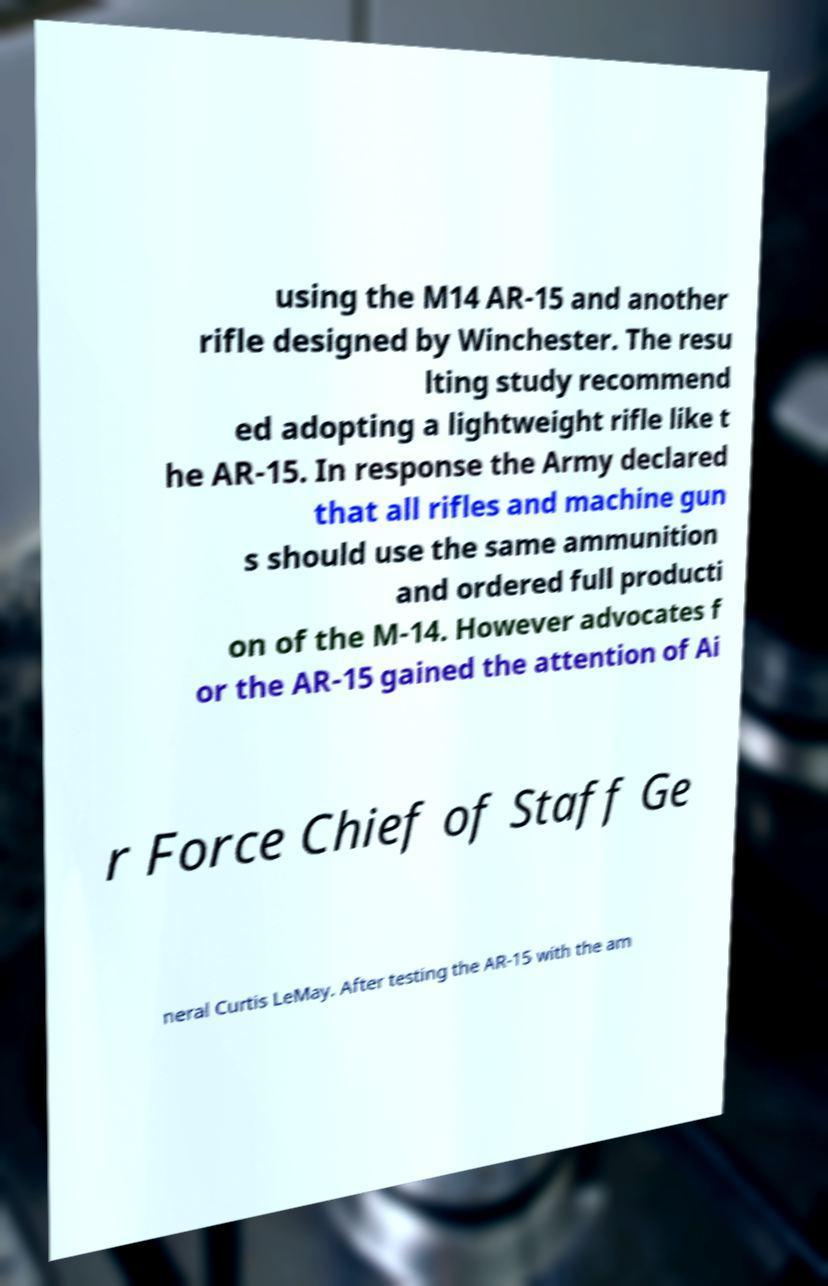Please read and relay the text visible in this image. What does it say? using the M14 AR-15 and another rifle designed by Winchester. The resu lting study recommend ed adopting a lightweight rifle like t he AR-15. In response the Army declared that all rifles and machine gun s should use the same ammunition and ordered full producti on of the M-14. However advocates f or the AR-15 gained the attention of Ai r Force Chief of Staff Ge neral Curtis LeMay. After testing the AR-15 with the am 